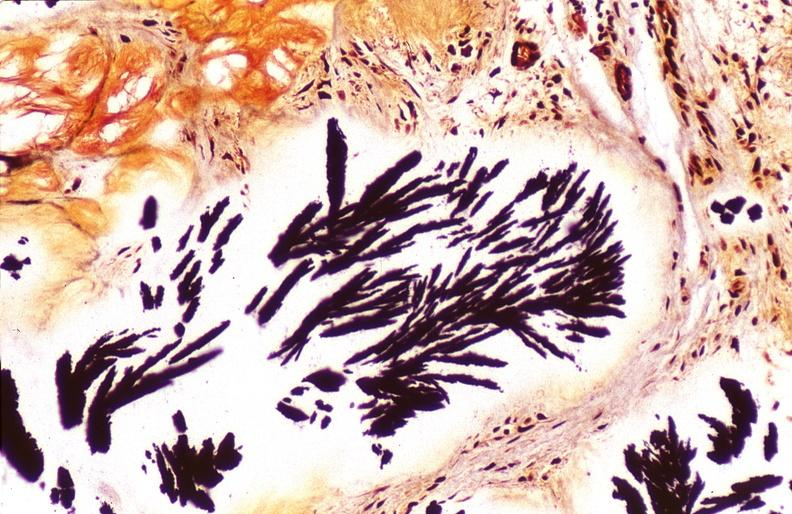s joints present?
Answer the question using a single word or phrase. Yes 